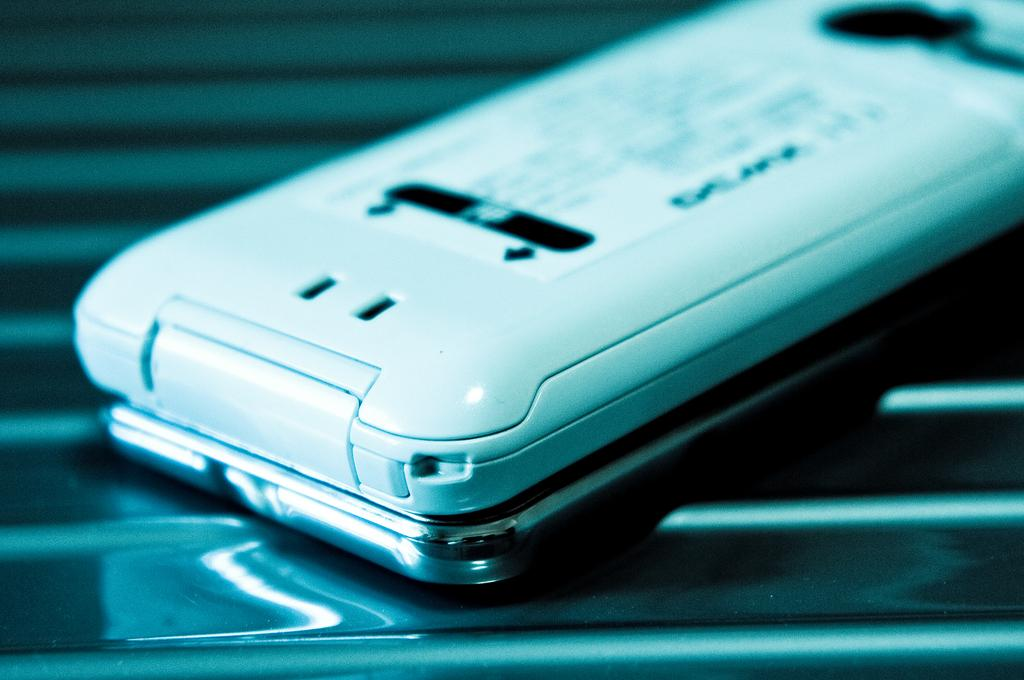What electronic device is visible in the image? There is a mobile phone in the image. Can you describe the background of the image? The background of the image is blurry. What is attached to the mobile phone? There is a paper pasted to the mobile phone. What type of mine is visible in the image? There is no mine present in the image; it features a mobile phone with a paper pasted to it. 